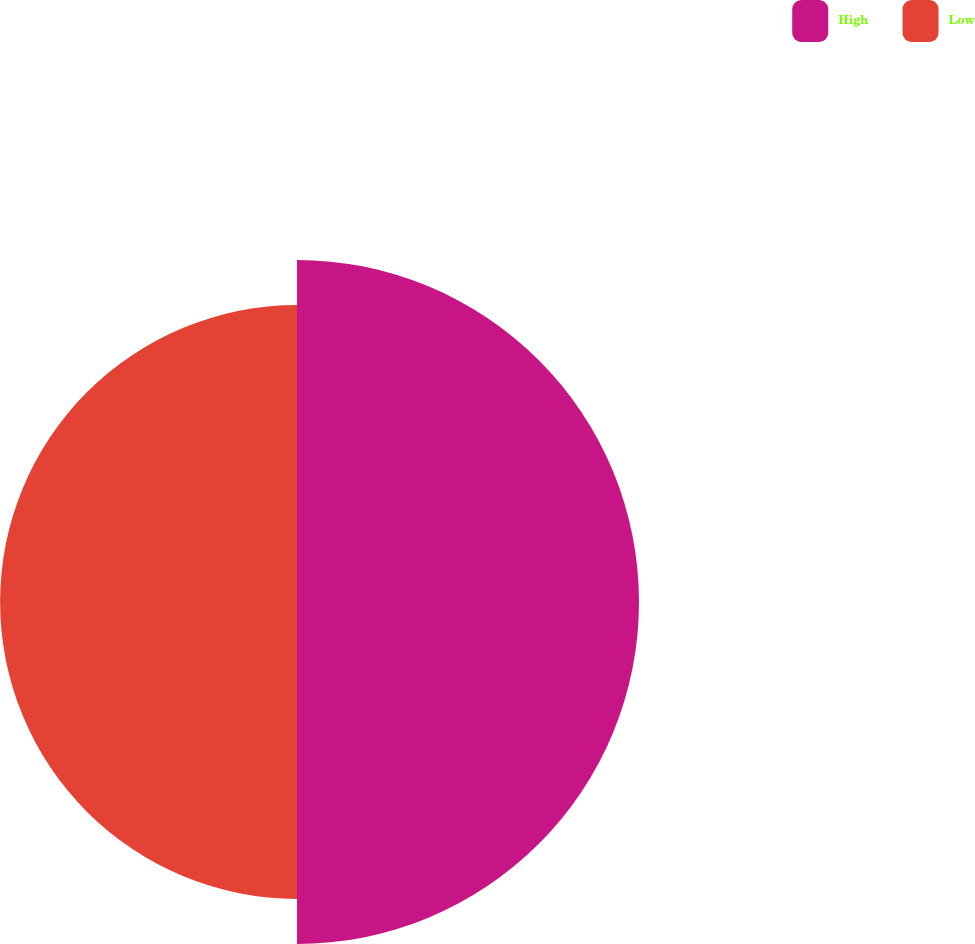Convert chart. <chart><loc_0><loc_0><loc_500><loc_500><pie_chart><fcel>High<fcel>Low<nl><fcel>53.53%<fcel>46.47%<nl></chart> 